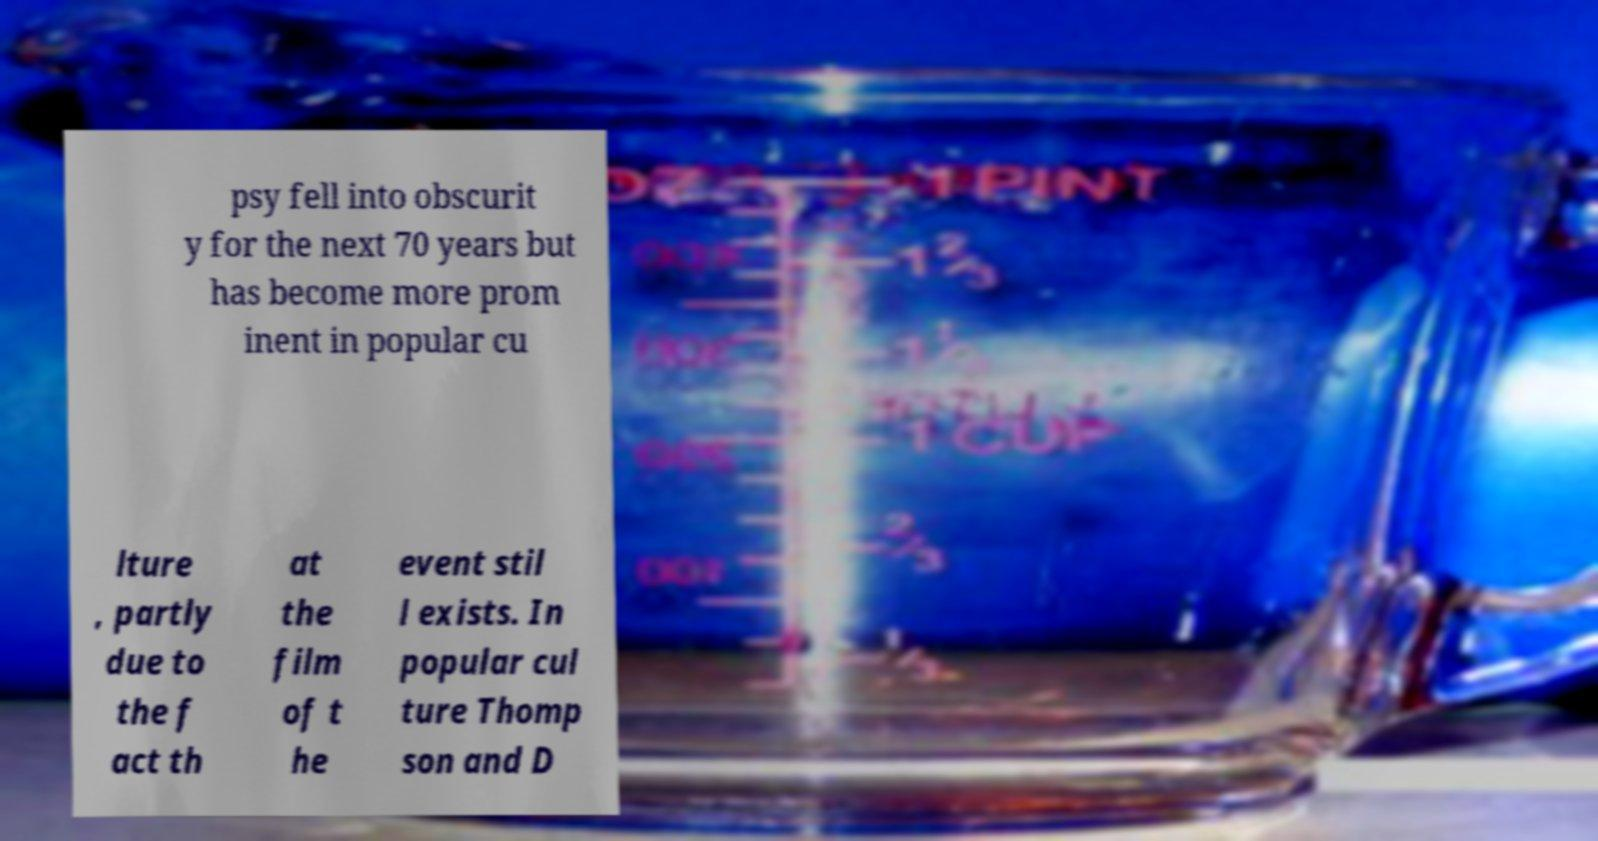I need the written content from this picture converted into text. Can you do that? psy fell into obscurit y for the next 70 years but has become more prom inent in popular cu lture , partly due to the f act th at the film of t he event stil l exists. In popular cul ture Thomp son and D 